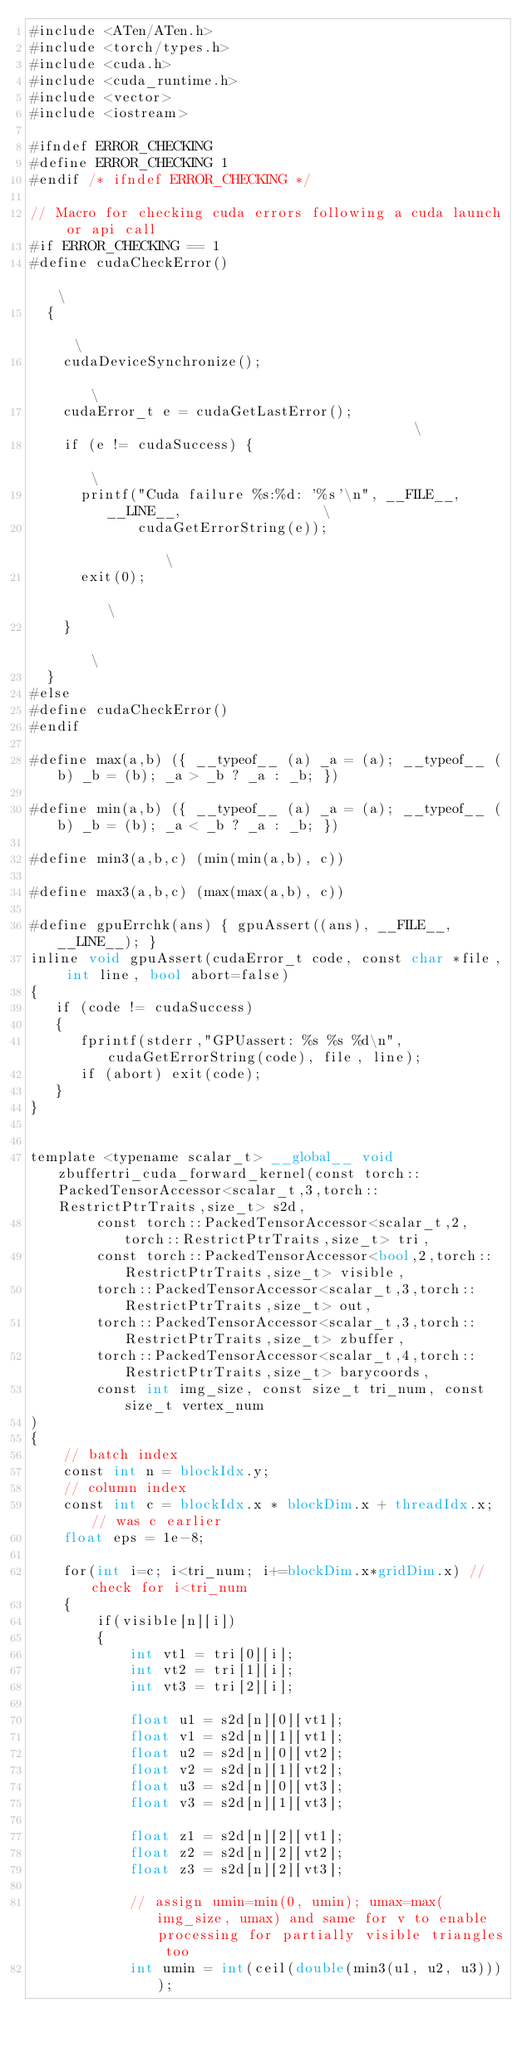<code> <loc_0><loc_0><loc_500><loc_500><_Cuda_>#include <ATen/ATen.h>
#include <torch/types.h>
#include <cuda.h>
#include <cuda_runtime.h>
#include <vector>
#include <iostream>

#ifndef ERROR_CHECKING
#define ERROR_CHECKING 1
#endif /* ifndef ERROR_CHECKING */

// Macro for checking cuda errors following a cuda launch or api call
#if ERROR_CHECKING == 1
#define cudaCheckError()                                                       \
  {                                                                            \
    cudaDeviceSynchronize();                                                   \
    cudaError_t e = cudaGetLastError();                                        \
    if (e != cudaSuccess) {                                                    \
      printf("Cuda failure %s:%d: '%s'\n", __FILE__, __LINE__,                 \
             cudaGetErrorString(e));                                           \
      exit(0);                                                                 \
    }                                                                          \
  }
#else
#define cudaCheckError()
#endif

#define max(a,b) ({ __typeof__ (a) _a = (a); __typeof__ (b) _b = (b); _a > _b ? _a : _b; })

#define min(a,b) ({ __typeof__ (a) _a = (a); __typeof__ (b) _b = (b); _a < _b ? _a : _b; })

#define min3(a,b,c) (min(min(a,b), c))

#define max3(a,b,c) (max(max(a,b), c))

#define gpuErrchk(ans) { gpuAssert((ans), __FILE__, __LINE__); }
inline void gpuAssert(cudaError_t code, const char *file, int line, bool abort=false)
{
   if (code != cudaSuccess)
   {
      fprintf(stderr,"GPUassert: %s %s %d\n", cudaGetErrorString(code), file, line);
      if (abort) exit(code);
   }
}


template <typename scalar_t> __global__ void zbuffertri_cuda_forward_kernel(const torch::PackedTensorAccessor<scalar_t,3,torch::RestrictPtrTraits,size_t> s2d,
        const torch::PackedTensorAccessor<scalar_t,2,torch::RestrictPtrTraits,size_t> tri,
        const torch::PackedTensorAccessor<bool,2,torch::RestrictPtrTraits,size_t> visible,
        torch::PackedTensorAccessor<scalar_t,3,torch::RestrictPtrTraits,size_t> out,
        torch::PackedTensorAccessor<scalar_t,3,torch::RestrictPtrTraits,size_t> zbuffer,
        torch::PackedTensorAccessor<scalar_t,4,torch::RestrictPtrTraits,size_t> barycoords,
        const int img_size, const size_t tri_num, const size_t vertex_num
)
{
    // batch index
    const int n = blockIdx.y;
    // column index
    const int c = blockIdx.x * blockDim.x + threadIdx.x; // was c earlier
    float eps = 1e-8;

    for(int i=c; i<tri_num; i+=blockDim.x*gridDim.x) //check for i<tri_num
    {
        if(visible[n][i])
        {
            int vt1 = tri[0][i];
            int vt2 = tri[1][i];
            int vt3 = tri[2][i];

            float u1 = s2d[n][0][vt1];
            float v1 = s2d[n][1][vt1];
            float u2 = s2d[n][0][vt2];
            float v2 = s2d[n][1][vt2];
            float u3 = s2d[n][0][vt3];
            float v3 = s2d[n][1][vt3];

            float z1 = s2d[n][2][vt1];
            float z2 = s2d[n][2][vt2];
            float z3 = s2d[n][2][vt3];

            // assign umin=min(0, umin); umax=max(img_size, umax) and same for v to enable processing for partially visible triangles too
            int umin = int(ceil(double(min3(u1, u2, u3))));</code> 